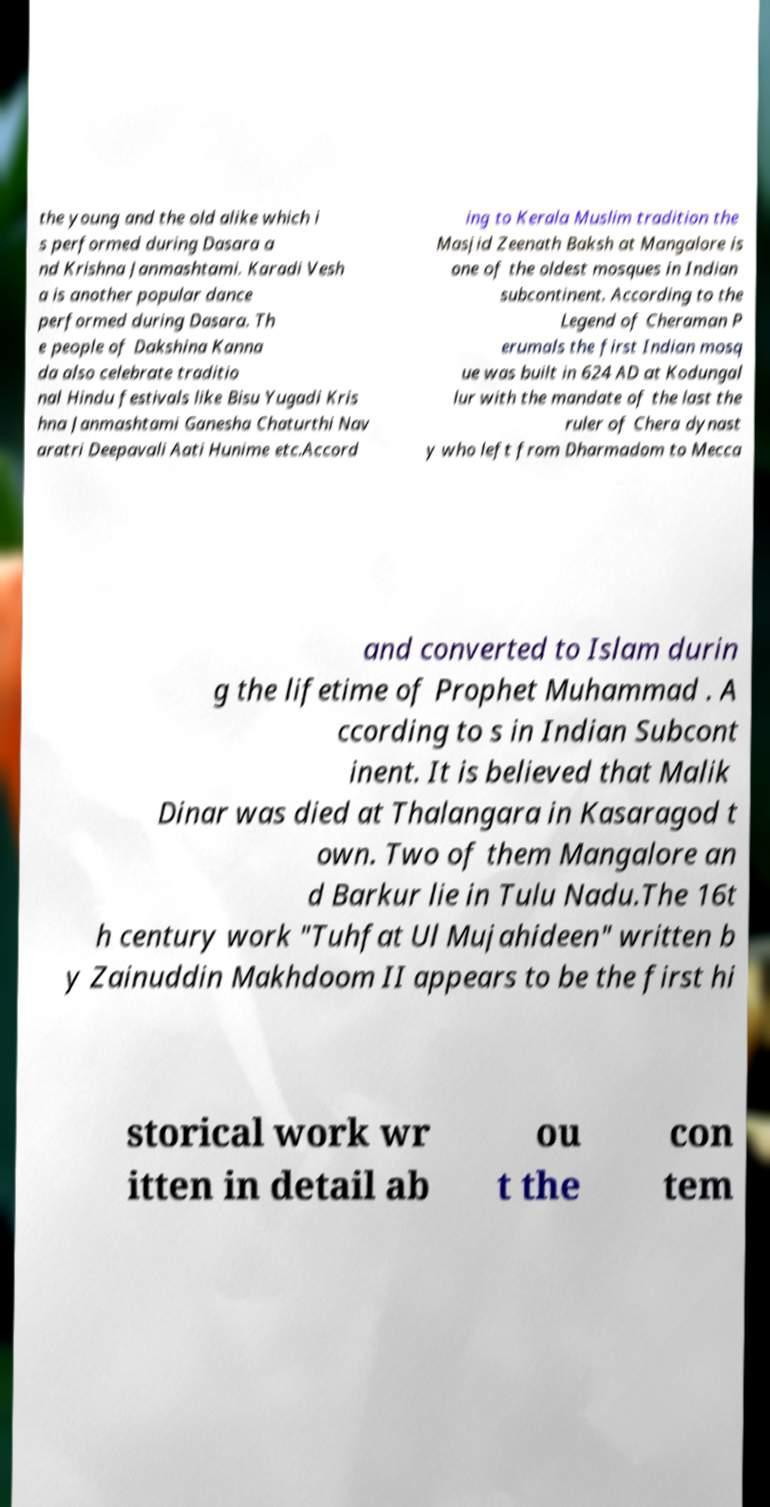For documentation purposes, I need the text within this image transcribed. Could you provide that? the young and the old alike which i s performed during Dasara a nd Krishna Janmashtami. Karadi Vesh a is another popular dance performed during Dasara. Th e people of Dakshina Kanna da also celebrate traditio nal Hindu festivals like Bisu Yugadi Kris hna Janmashtami Ganesha Chaturthi Nav aratri Deepavali Aati Hunime etc.Accord ing to Kerala Muslim tradition the Masjid Zeenath Baksh at Mangalore is one of the oldest mosques in Indian subcontinent. According to the Legend of Cheraman P erumals the first Indian mosq ue was built in 624 AD at Kodungal lur with the mandate of the last the ruler of Chera dynast y who left from Dharmadom to Mecca and converted to Islam durin g the lifetime of Prophet Muhammad . A ccording to s in Indian Subcont inent. It is believed that Malik Dinar was died at Thalangara in Kasaragod t own. Two of them Mangalore an d Barkur lie in Tulu Nadu.The 16t h century work "Tuhfat Ul Mujahideen" written b y Zainuddin Makhdoom II appears to be the first hi storical work wr itten in detail ab ou t the con tem 